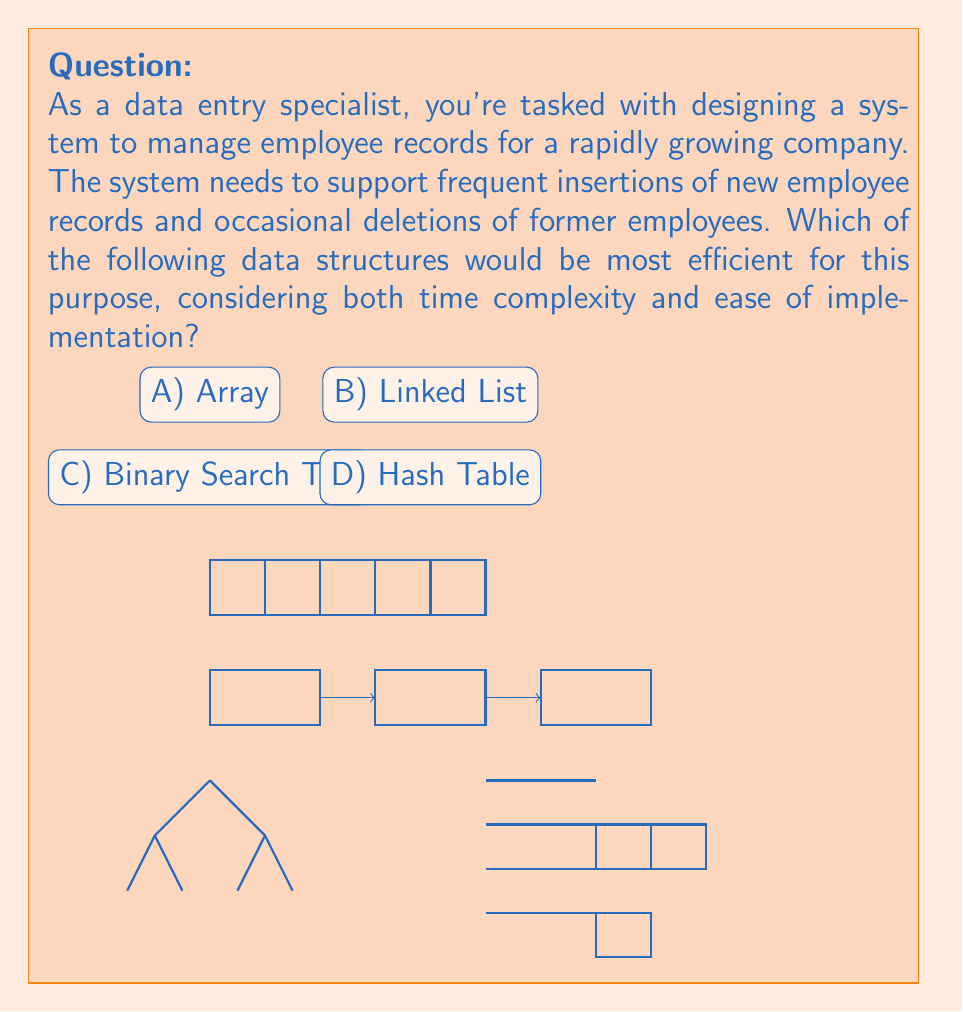Give your solution to this math problem. Let's analyze each data structure in terms of insertion and deletion efficiency:

1. Array:
   - Insertion: $O(n)$ in worst case (when array is full and needs resizing)
   - Deletion: $O(n)$ (need to shift elements after deletion)
   - Easy to implement but not efficient for frequent insertions/deletions

2. Linked List:
   - Insertion: $O(1)$ at head/tail, $O(n)$ for arbitrary position
   - Deletion: $O(1)$ if node is given, $O(n)$ to find the node
   - Better than array for frequent insertions but still not optimal

3. Binary Search Tree:
   - Insertion: $O(\log n)$ average case, $O(n)$ worst case
   - Deletion: $O(\log n)$ average case, $O(n)$ worst case
   - Efficient but can become unbalanced, complicating implementation

4. Hash Table:
   - Insertion: $O(1)$ average case
   - Deletion: $O(1)$ average case
   - Very efficient for both operations and relatively easy to implement

For a system requiring frequent insertions and occasional deletions, a Hash Table provides the best balance of efficiency and ease of implementation. It offers constant-time average-case complexity for both operations, making it ideal for managing employee records in a growing company.

Hash Tables use a hash function to map keys (e.g., employee IDs) to array indices, allowing for quick access, insertion, and deletion. While there can be collisions (two keys mapping to the same index), proper collision resolution techniques (like chaining or open addressing) can maintain the $O(1)$ average-case time complexity.
Answer: D) Hash Table 